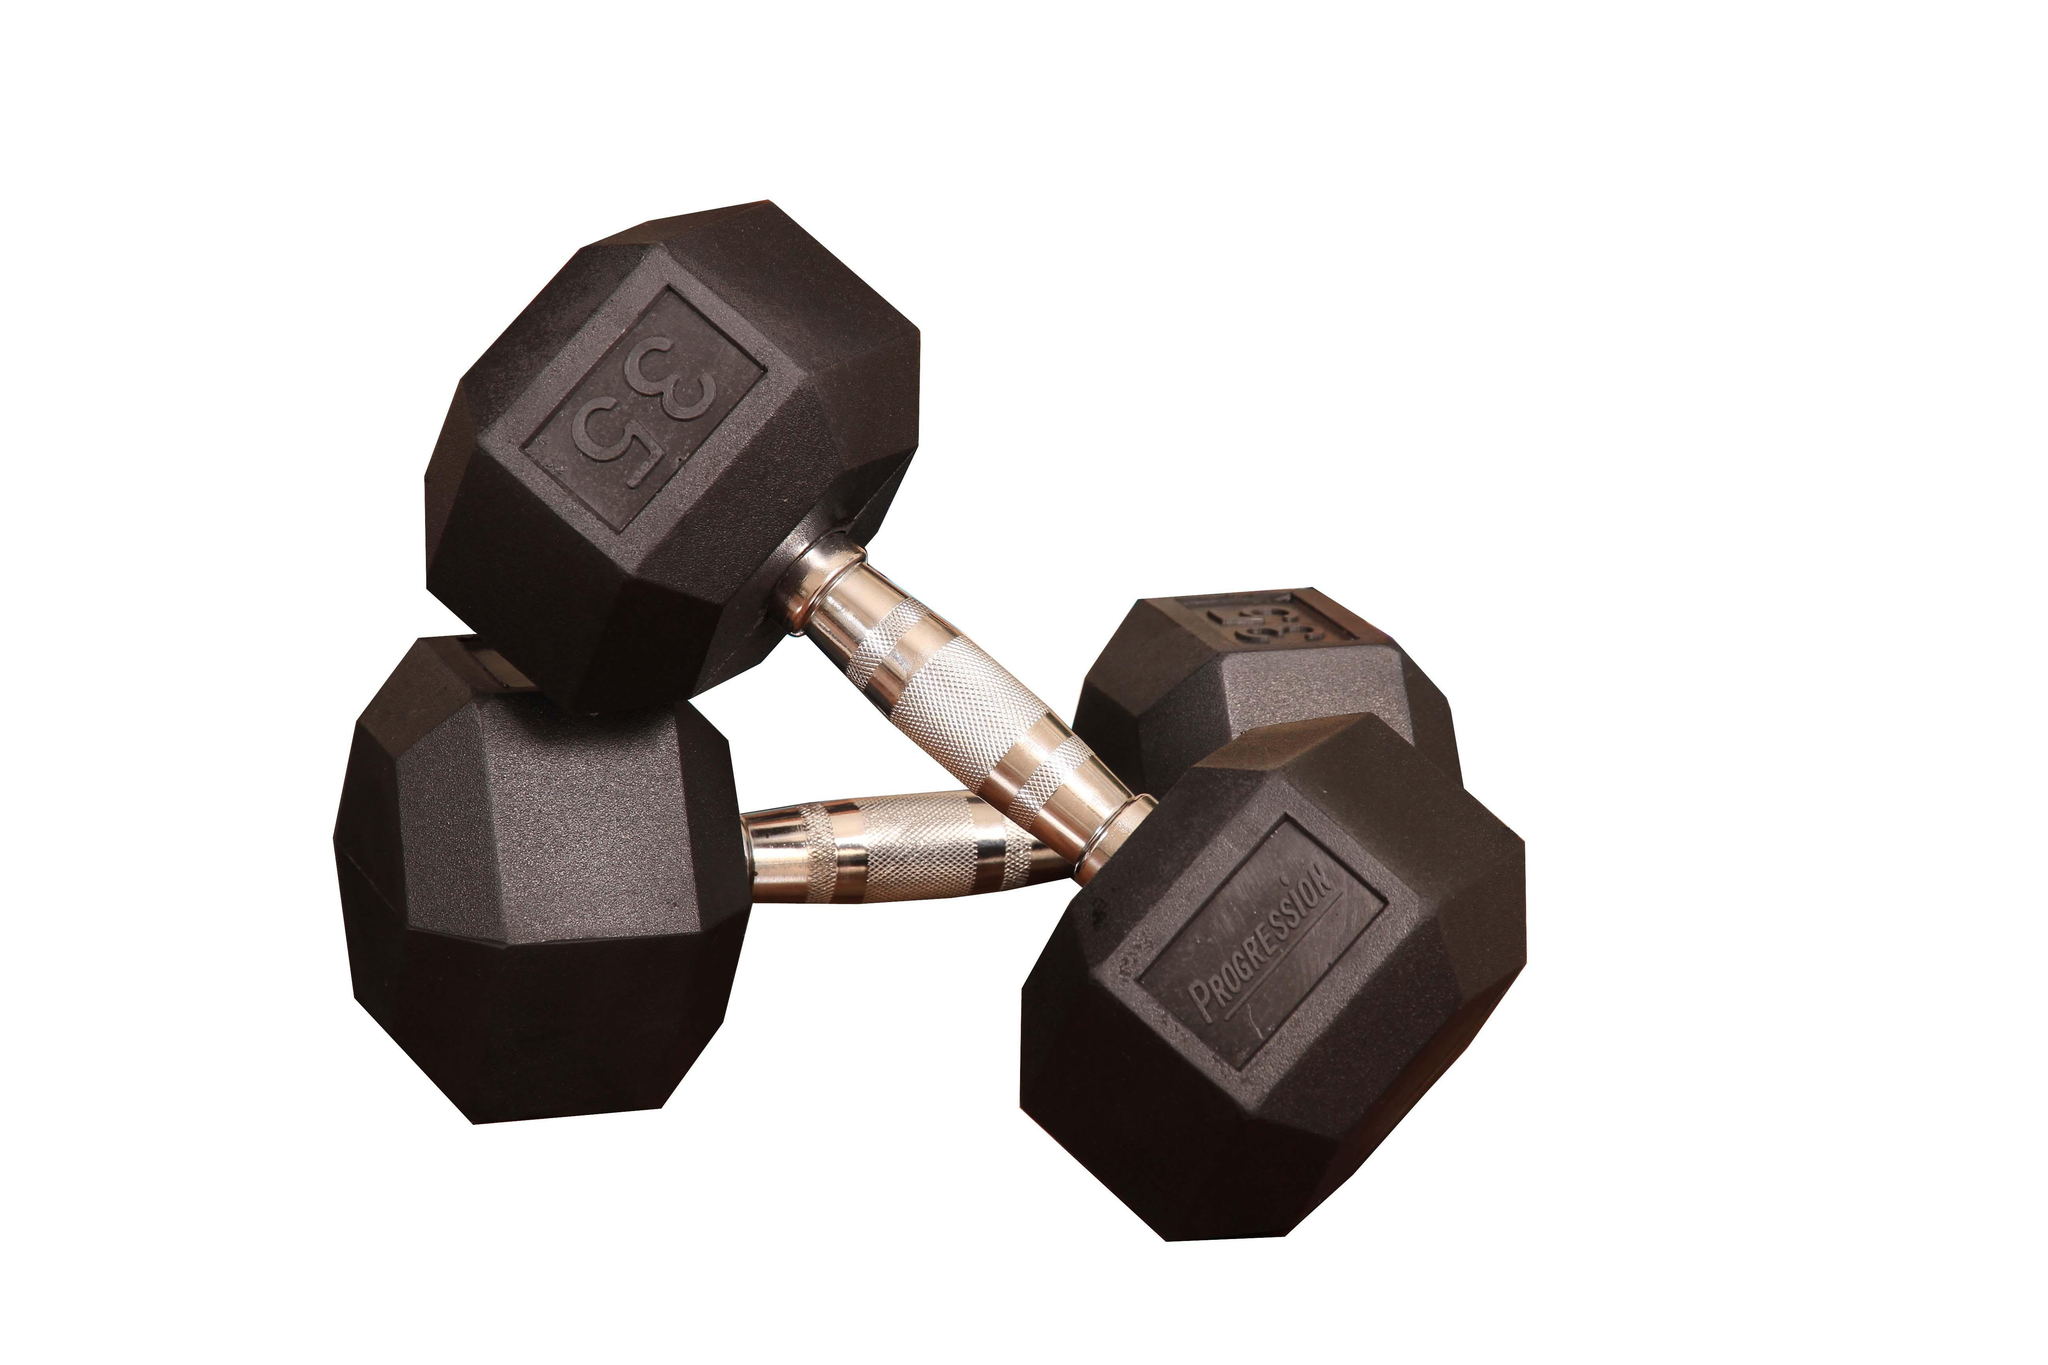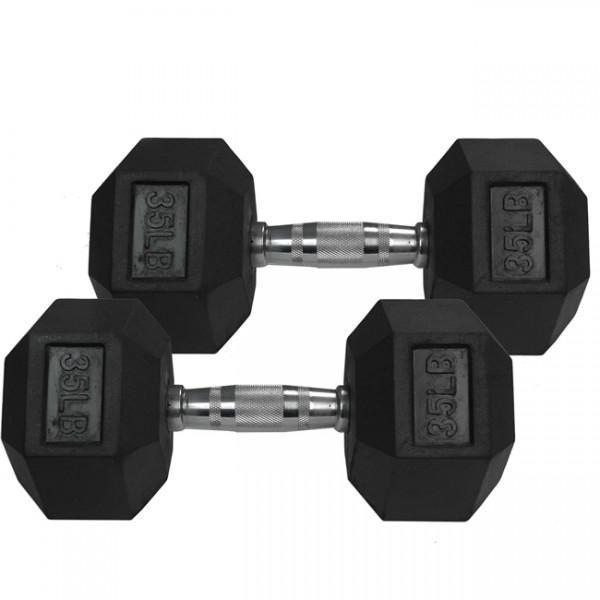The first image is the image on the left, the second image is the image on the right. Analyze the images presented: Is the assertion "Two hand weights in each image are a matched set, dark colored weights with six sides that are attached to a metal bar." valid? Answer yes or no. Yes. The first image is the image on the left, the second image is the image on the right. Analyze the images presented: Is the assertion "The right image contains two dumbbells with black ends and a chrome middle bar." valid? Answer yes or no. Yes. 